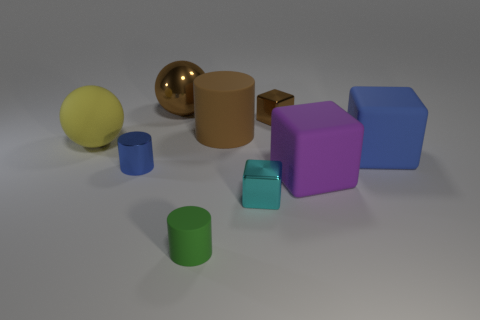Subtract all brown blocks. How many blocks are left? 3 Subtract all yellow spheres. How many spheres are left? 1 Subtract all cubes. How many objects are left? 5 Subtract 2 blocks. How many blocks are left? 2 Subtract all purple cubes. Subtract all brown balls. How many cubes are left? 3 Subtract all large blue things. Subtract all yellow spheres. How many objects are left? 7 Add 6 metallic cylinders. How many metallic cylinders are left? 7 Add 7 gray things. How many gray things exist? 7 Subtract 1 brown cylinders. How many objects are left? 8 